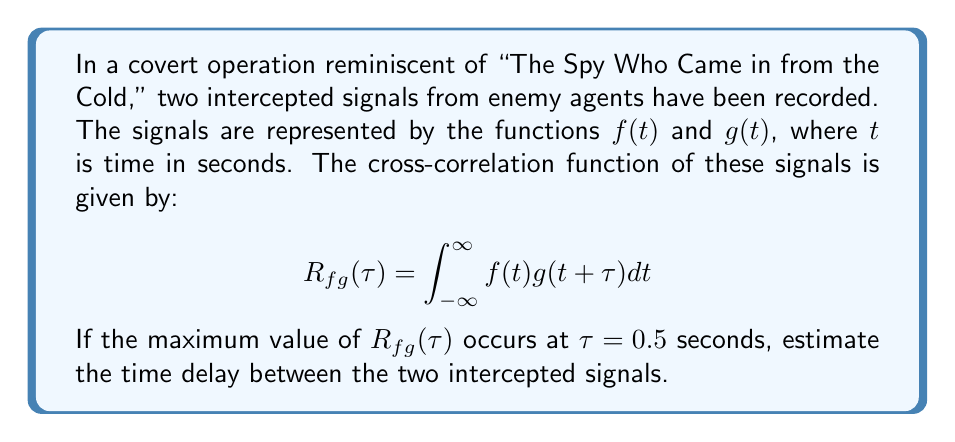Help me with this question. To solve this problem, we need to understand the concept of cross-correlation and its application in estimating time delays between signals. Let's break it down step-by-step:

1) Cross-correlation is a measure of similarity between two signals as a function of the time lag between them. The cross-correlation function $R_{fg}(\tau)$ measures how similar $f(t)$ is to $g(t+\tau)$ for different values of the time lag $\tau$.

2) In the context of signal processing, the time lag $\tau$ at which the cross-correlation function reaches its maximum value indicates the time delay between the two signals.

3) This is because when the time lag $\tau$ is equal to the actual time delay between the signals, the shifted version of one signal (g(t+τ)) will align best with the other signal (f(t)), resulting in the highest correlation.

4) In this problem, we're given that the maximum value of $R_{fg}(\tau)$ occurs at $\tau = 0.5$ seconds.

5) This means that $g(t)$ is most similar to $f(t-0.5)$, or equivalently, $f(t)$ is most similar to $g(t+0.5)$.

6) Therefore, we can conclude that $g(t)$ is a delayed version of $f(t)$, with a delay of 0.5 seconds.

In the context of intercepted spy signals, this suggests that the second signal (g(t)) was transmitted 0.5 seconds after the first signal (f(t)).
Answer: The estimated time delay between the two intercepted signals is 0.5 seconds. 